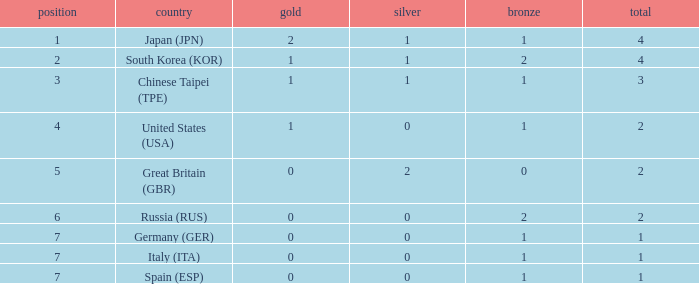What is the smallest number of gold of a country of rank 6, with 2 bronzes? None. 